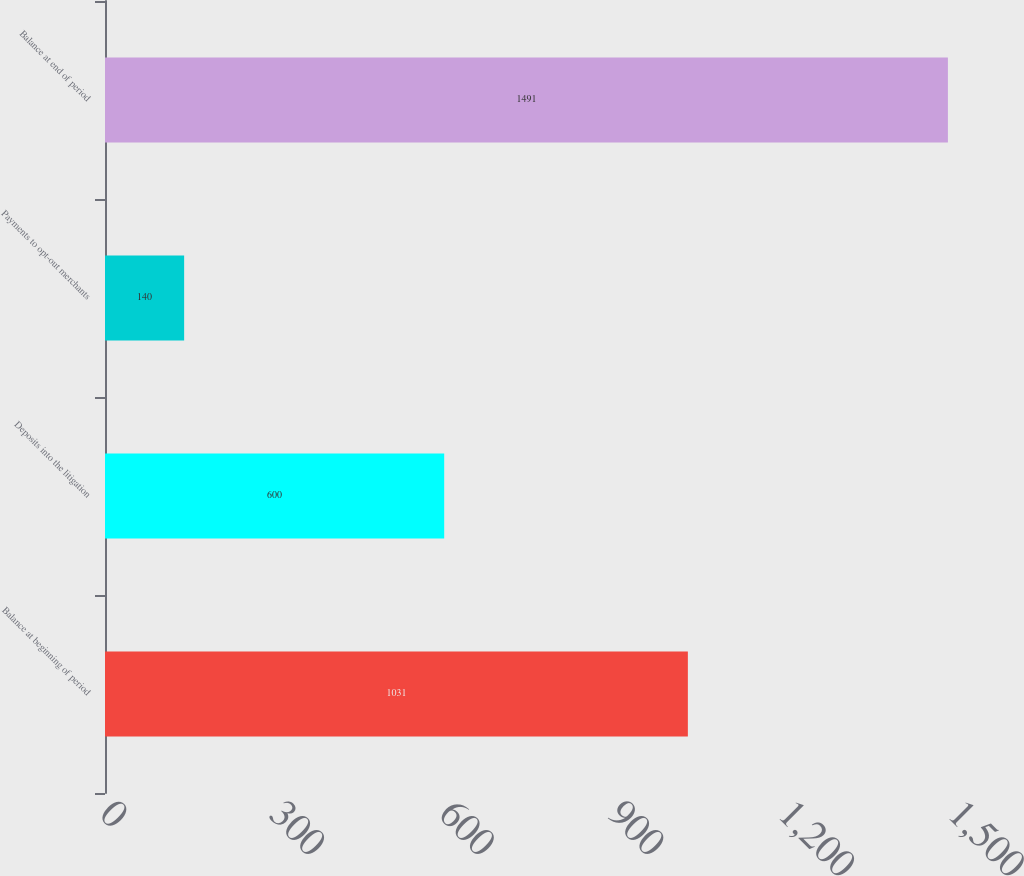<chart> <loc_0><loc_0><loc_500><loc_500><bar_chart><fcel>Balance at beginning of period<fcel>Deposits into the litigation<fcel>Payments to opt-out merchants<fcel>Balance at end of period<nl><fcel>1031<fcel>600<fcel>140<fcel>1491<nl></chart> 